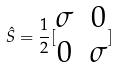Convert formula to latex. <formula><loc_0><loc_0><loc_500><loc_500>\hat { S } = \frac { 1 } { 2 } [ \begin{matrix} \sigma & 0 \\ 0 & \sigma \end{matrix} ]</formula> 